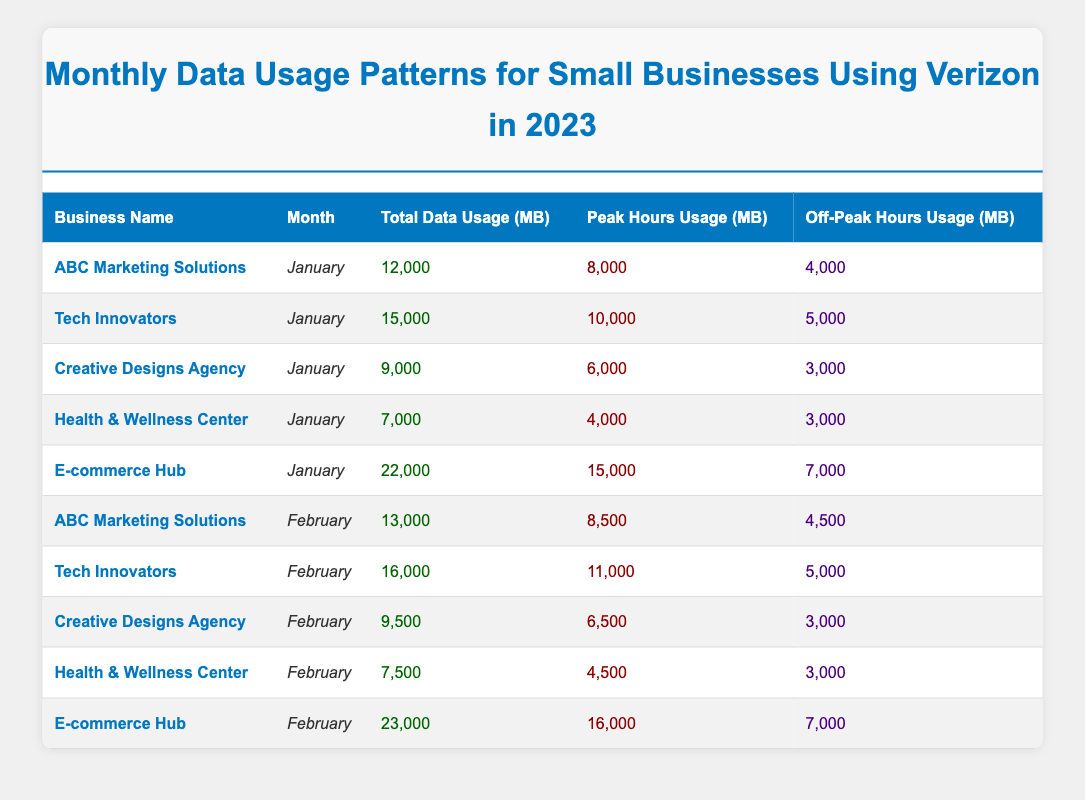What is the total data usage for ABC Marketing Solutions in January? The table shows that ABC Marketing Solutions used 12,000 MB in January.
Answer: 12,000 MB In February, which business had the highest peak hours data usage? According to the table, E-commerce Hub had the highest peak hours data usage in February with 16,000 MB.
Answer: E-commerce Hub What is the average total data usage across all businesses for January? To find the average, sum the total data usage for January: (12,000 + 15,000 + 9,000 + 7,000 + 22,000) = 65,000. Then divide by the number of businesses (5): 65,000 / 5 = 13,000 MB.
Answer: 13,000 MB Did Creative Designs Agency use more data in January than in February? In January, Creative Designs Agency used 9,000 MB while in February, it used 9,500 MB. Since 9,500 MB is greater than 9,000 MB, the answer is no.
Answer: No How much more total data did E-commerce Hub use in February compared to January? E-commerce Hub used 23,000 MB in February and 22,000 MB in January. The difference is 23,000 - 22,000 = 1,000 MB.
Answer: 1,000 MB What percentage of total data usage for January did off-peak hours represent for Tech Innovators? Tech Innovators used 15,000 MB total in January, with 5,000 MB during off-peak hours. To find the percentage: (5,000 / 15,000) * 100 = 33.33%.
Answer: 33.33% Is the peak hours data usage for Health & Wellness Center in February greater than or equal to its January usage? In January, Health & Wellness Center used 4,000 MB during peak hours, and in February it used 4,500 MB during peak hours. Since 4,500 MB is greater than 4,000 MB, the answer is yes.
Answer: Yes What is the total off-peak hours data usage for all businesses in February? The off-peak hours data usage for February is: 4,500 (ABC Marketing Solutions) + 5,000 (Tech Innovators) + 3,000 (Creative Designs Agency) + 3,000 (Health & Wellness Center) + 7,000 (E-commerce Hub) = 22,500 MB.
Answer: 22,500 MB Which month had a higher average peak hours usage, January or February? For January, the average peak hours usage is: (8,000 + 10,000 + 6,000 + 4,000 + 15,000) = 43,000; then, 43,000 / 5 = 8,600 MB. For February: (8,500 + 11,000 + 6,500 + 4,500 + 16,000) = 46,500; then, 46,500 / 5 = 9,300 MB. Since 9,300 MB is greater than 8,600 MB, February had a higher average.
Answer: February 